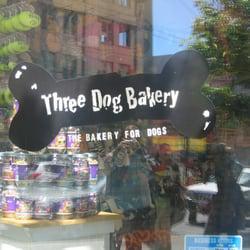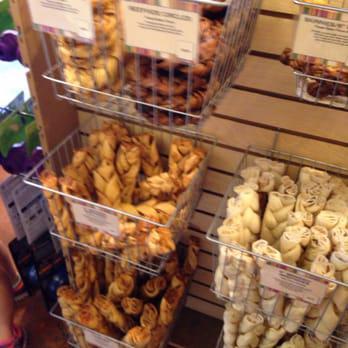The first image is the image on the left, the second image is the image on the right. Assess this claim about the two images: "The right image shows a glass display case containing white trays of glazed and coated ball-shaped treats with stick handles.". Correct or not? Answer yes or no. No. The first image is the image on the left, the second image is the image on the right. Examine the images to the left and right. Is the description "One of the cases has four shelves displaying different baked goods." accurate? Answer yes or no. No. 